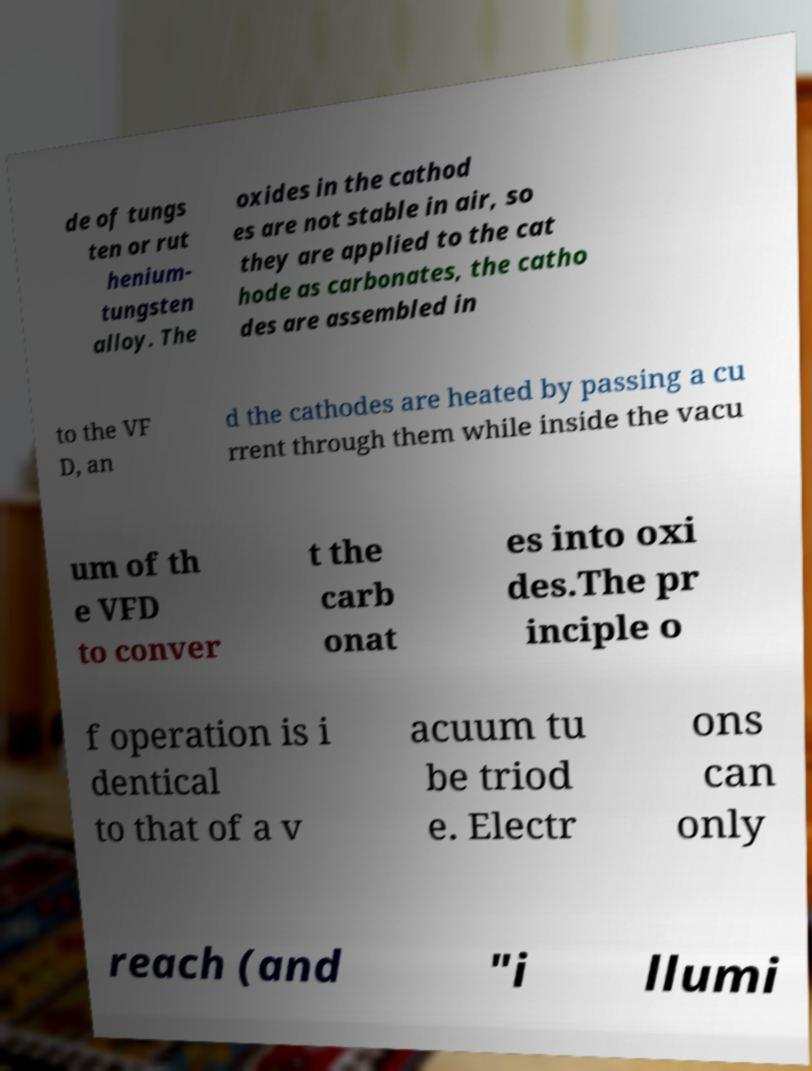I need the written content from this picture converted into text. Can you do that? de of tungs ten or rut henium- tungsten alloy. The oxides in the cathod es are not stable in air, so they are applied to the cat hode as carbonates, the catho des are assembled in to the VF D, an d the cathodes are heated by passing a cu rrent through them while inside the vacu um of th e VFD to conver t the carb onat es into oxi des.The pr inciple o f operation is i dentical to that of a v acuum tu be triod e. Electr ons can only reach (and "i llumi 